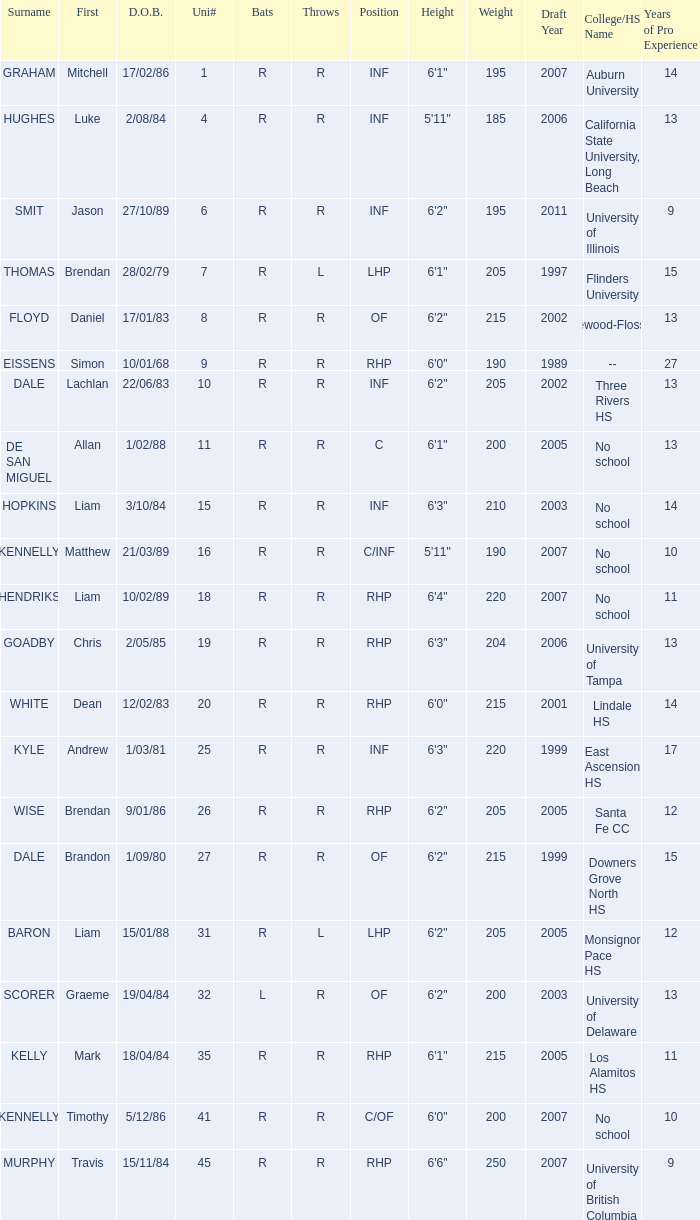Who is the player with the last name baron? R. 